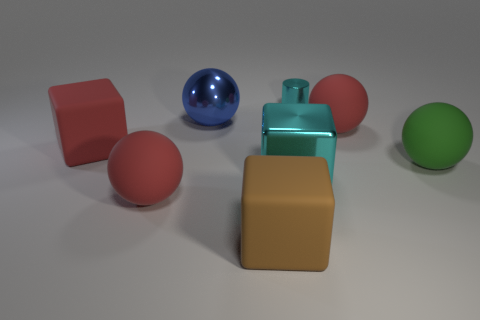Subtract all big green rubber spheres. How many spheres are left? 3 Subtract all yellow cubes. How many red balls are left? 2 Add 1 large blue rubber cylinders. How many objects exist? 9 Subtract all cyan cubes. How many cubes are left? 2 Subtract all cylinders. How many objects are left? 7 Subtract 1 cubes. How many cubes are left? 2 Add 4 red matte blocks. How many red matte blocks are left? 5 Add 4 shiny spheres. How many shiny spheres exist? 5 Subtract 0 gray spheres. How many objects are left? 8 Subtract all blue cylinders. Subtract all red cubes. How many cylinders are left? 1 